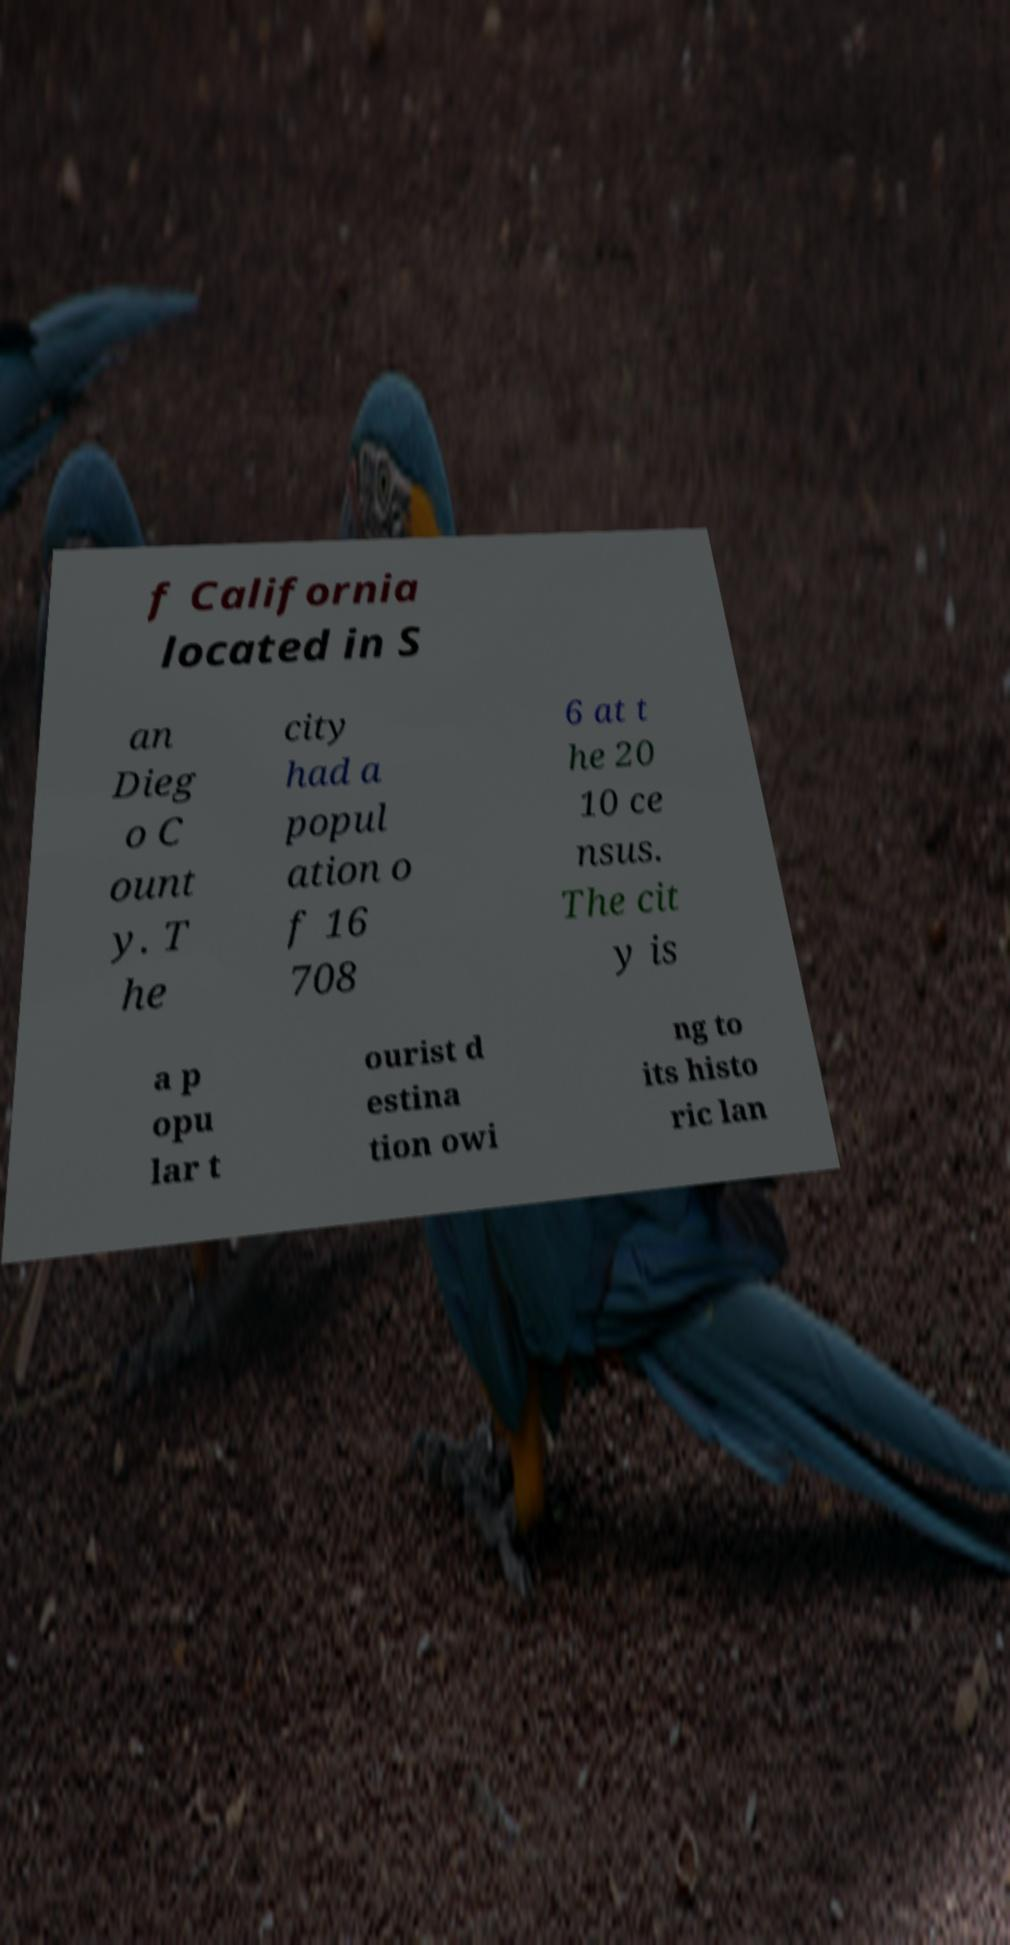There's text embedded in this image that I need extracted. Can you transcribe it verbatim? f California located in S an Dieg o C ount y. T he city had a popul ation o f 16 708 6 at t he 20 10 ce nsus. The cit y is a p opu lar t ourist d estina tion owi ng to its histo ric lan 